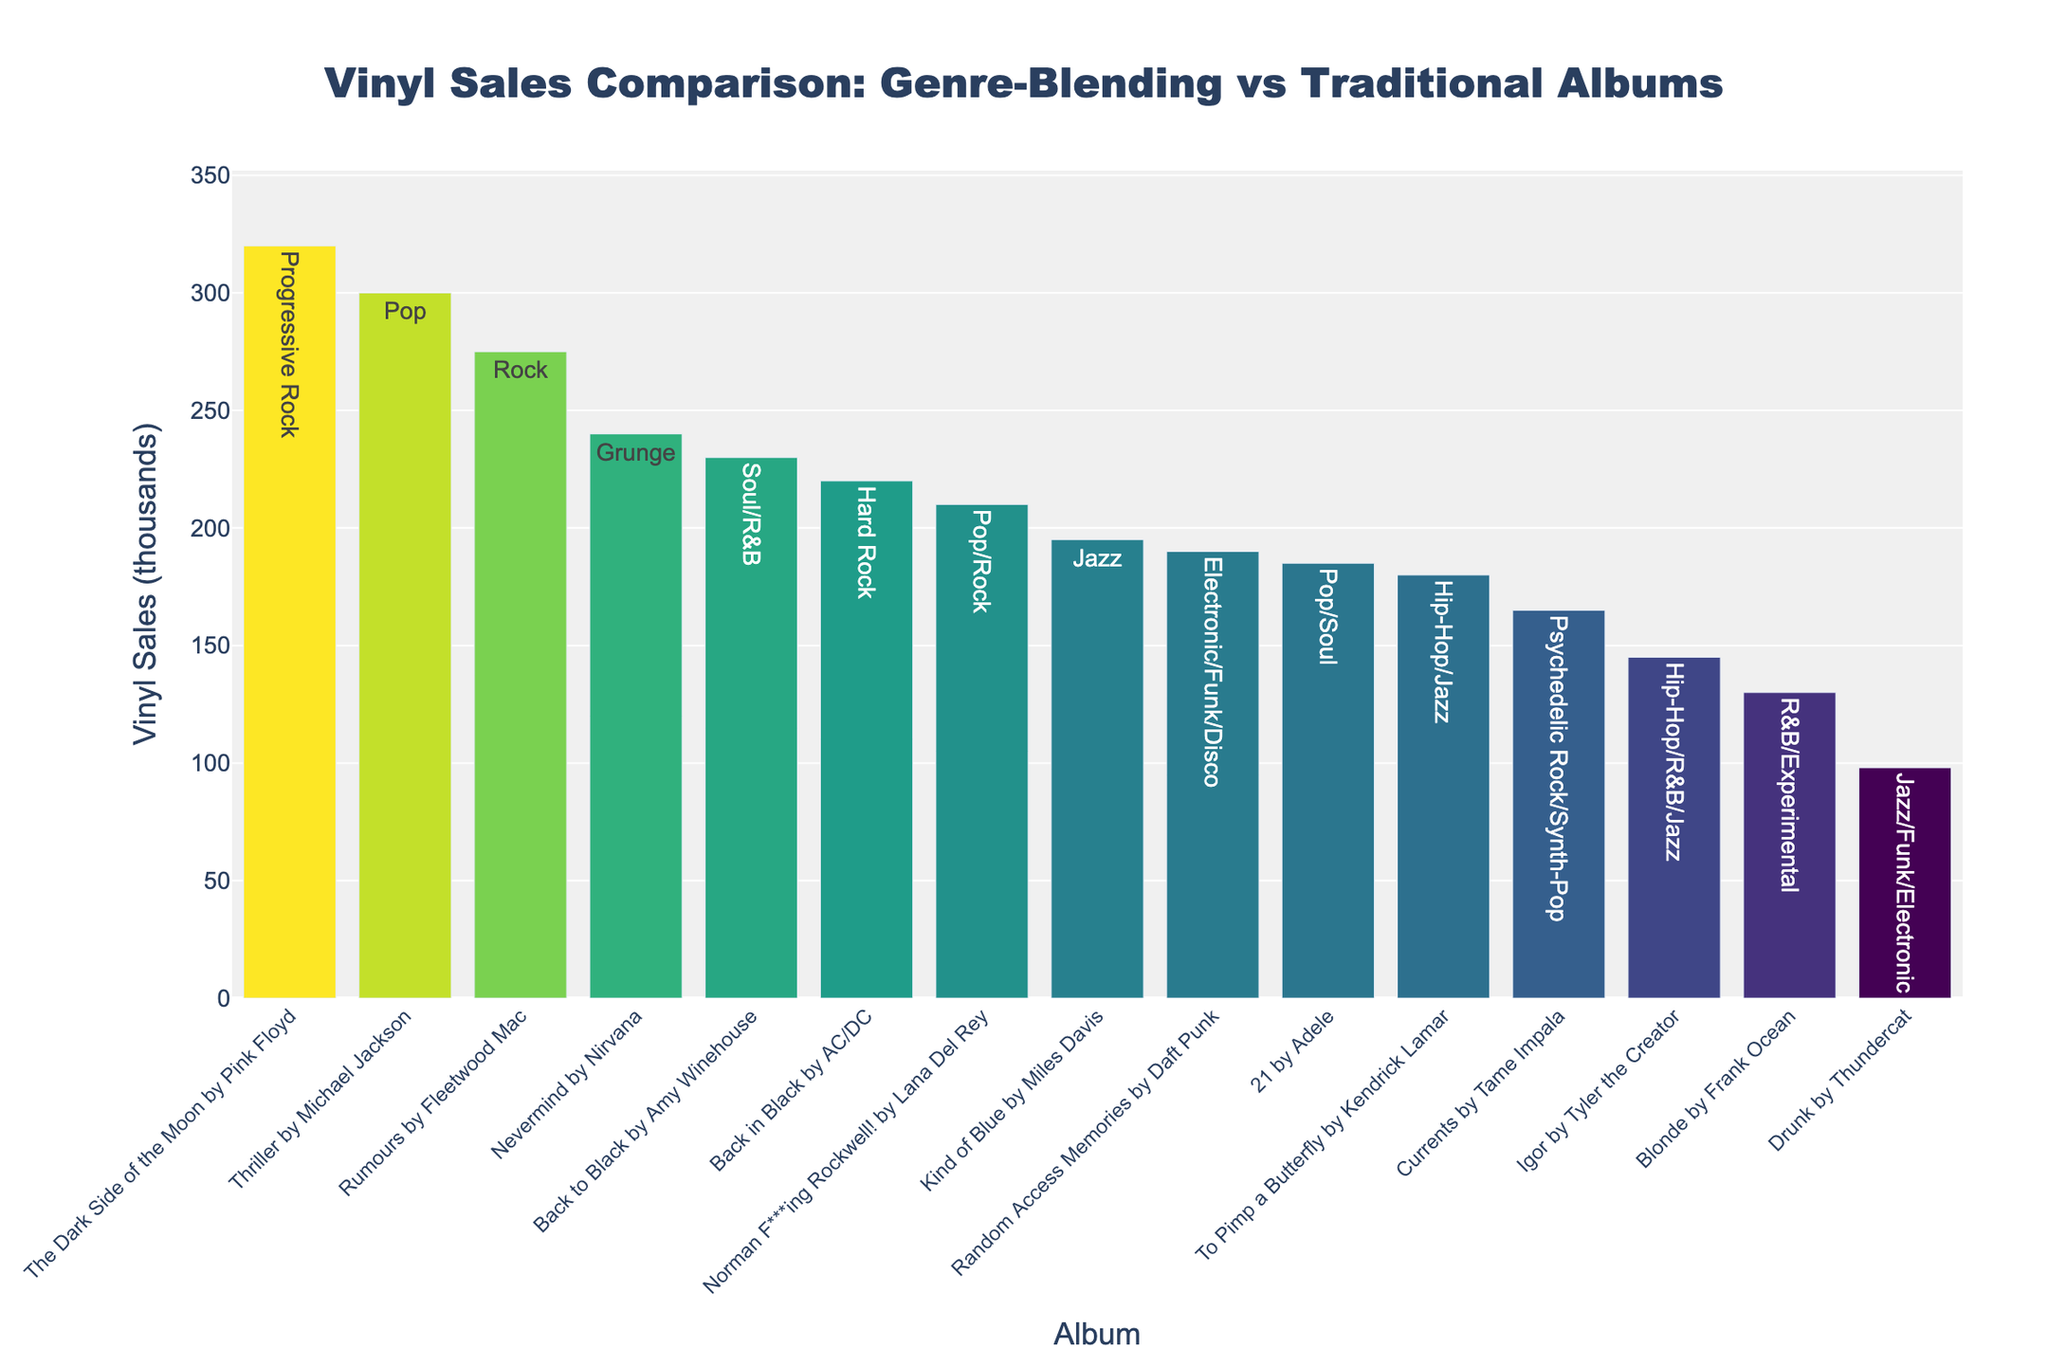Which album has the highest vinyl sales? The tallest bar represents the album with the highest sales. "The Dark Side of the Moon" by Pink Floyd has the tallest bar.
Answer: "The Dark Side of the Moon" by Pink Floyd Which genre-blending album has the highest vinyl sales? Identify the tallest bar among the bars labeled with genre combinations. "To Pimp a Butterfly" by Kendrick Lamar, labeled as Hip-Hop/Jazz, has the highest sales among genre-blending albums.
Answer: "To Pimp a Butterfly" by Kendrick Lamar How much higher are the vinyl sales of "Thriller" by Michael Jackson compared to "Igor" by Tyler the Creator? Subtract the sales of "Igor" (145k) from the sales of "Thriller" (300k). The result is 300k - 145k = 155k.
Answer: 155k What is the average vinyl sales of all the albums? Sum all the vinyl sales values and divide by the number of albums. The sum is (145 + 98 + 210 + 180 + 165 + 230 + 190 + 275 + 195 + 300 + 320 + 240 + 220 + 185 + 130) = 3083. Divide by 15 to get the average, 3083 / 15 = 205.53k.
Answer: 205.53k Which album has the lowest vinyl sales? The shortest bar represents the album with the lowest sales. "Drunk" by Thundercat has the shortest bar.
Answer: "Drunk" by Thundercat What is the total vinyl sales of the traditional genre albums? Sum the vinyl sales of albums labeled with traditional single genres. Those are "Rumours", "Kind of Blue", "Thriller", "The Dark Side of the Moon", "Nevermind", "Back in Black": (275 + 195 + 300 + 320 + 240 + 220) = 1550k.
Answer: 1550k Which album with the word "Black" in the title has the highest vinyl sales? Compare the sales of "Back to Black" by Amy Winehouse and "Back in Black" by AC/DC. "Back to Black" has higher sales (230k) compared to "Back in Black" (220k).
Answer: "Back to Black" by Amy Winehouse How do the sales of "Random Access Memories" by Daft Punk compare with the median sales of the dataset? First, order all sales values and find the middle one. Ordered sales: 98, 130, 145, 165, 180, 185, 190, 195, 210, 220, 230, 240, 275, 300, 320. The median sales value is the 8th value: 195k. "Random Access Memories" sales are equal to the median (190k is close to but less than 195k).
Answer: Close to median How many albums have sales greater than 200k? Count the bars with sales values higher than 200k, which are "Rumours", "Thriller", "The Dark Side of the Moon", "Nevermind", "Back in Black", and "Norman F***ing Rockwell!" (6 albums).
Answer: 6 What is the difference in sales between the highest-selling genre-blending album and the lowest-selling traditional genre album? "To Pimp a Butterfly" (highest genre-blending, 180k) and "Kind of Blue" (lowest traditional, 195k): The difference is 195k - 180k = 15k.
Answer: 15k 